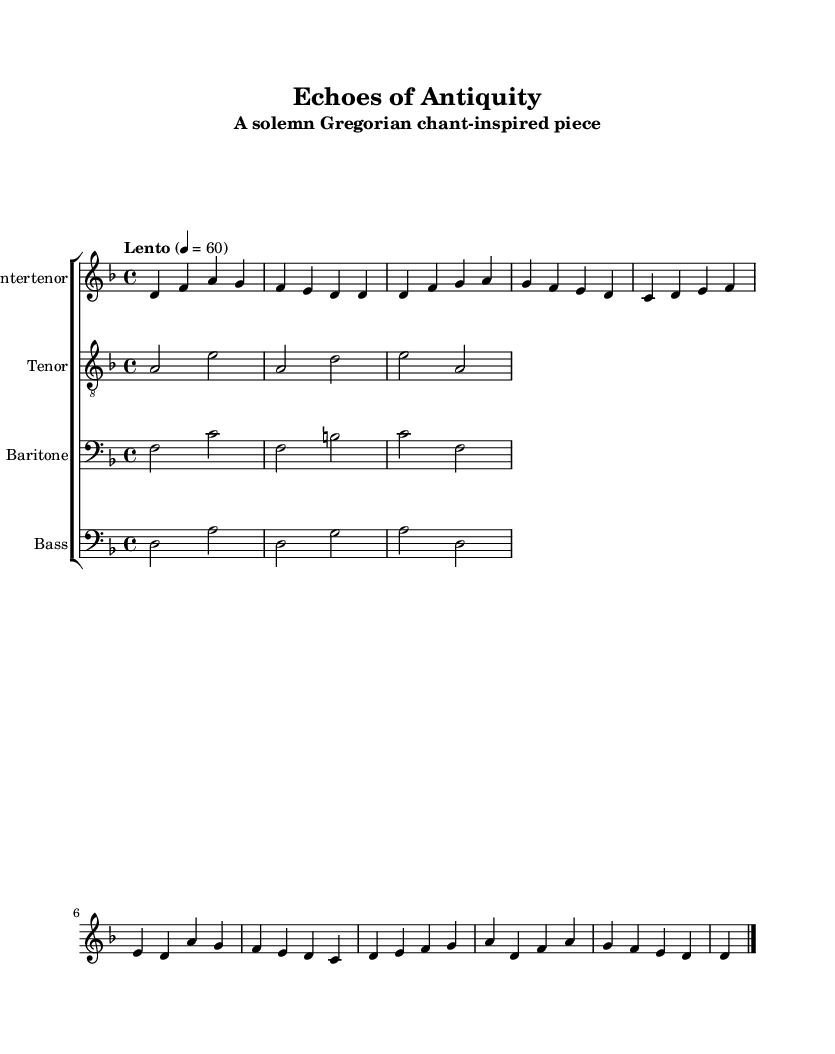What is the key signature of this music? The key signature indicates a D minor tonal center, which has one flat (B flat) as its only accidental. This can be determined from the key indicated at the beginning of the score.
Answer: D minor What is the time signature? The time signature is found after the key signature and shows a 4/4 structure, indicating four beats in each measure and a quarter note receiving one beat.
Answer: 4/4 What is the tempo marking? The tempo is specified at the beginning of the score as "Lento," which suggests a slow pace; it is further quantified as quarter note = 60 beats per minute.
Answer: Lento How many staves are present in this score? The score shows four separate staves for different vocal parts: Countertenor, Tenor, Baritone, and Bass. This can be deduced by visually counting the distinct parts labeled at the beginning of each staff line.
Answer: Four Which voice part has the highest range? The Countertenor part, indicated by the use of the treble clef and the range of notes it contains, is the highest in pitch when compared to Tenor, Baritone, and Bass parts. The treble clef positions the notes higher on the staff.
Answer: Countertenor What type of music does this piece represent? This piece reflects Gregorian chant characteristics, which include the use of modal scales, single melodic lines often sung in Latin, and a generally somber, meditative quality indicative of medieval liturgical music.
Answer: Gregorian chant What is the lyrical theme of the song? The lyrics depict themes of eternal truth and the ephemeral nature of time, as conveyed through phrases discussing memory, history, and wisdom, which are central to the text of many Gregorian chants.
Answer: Eternal truth 